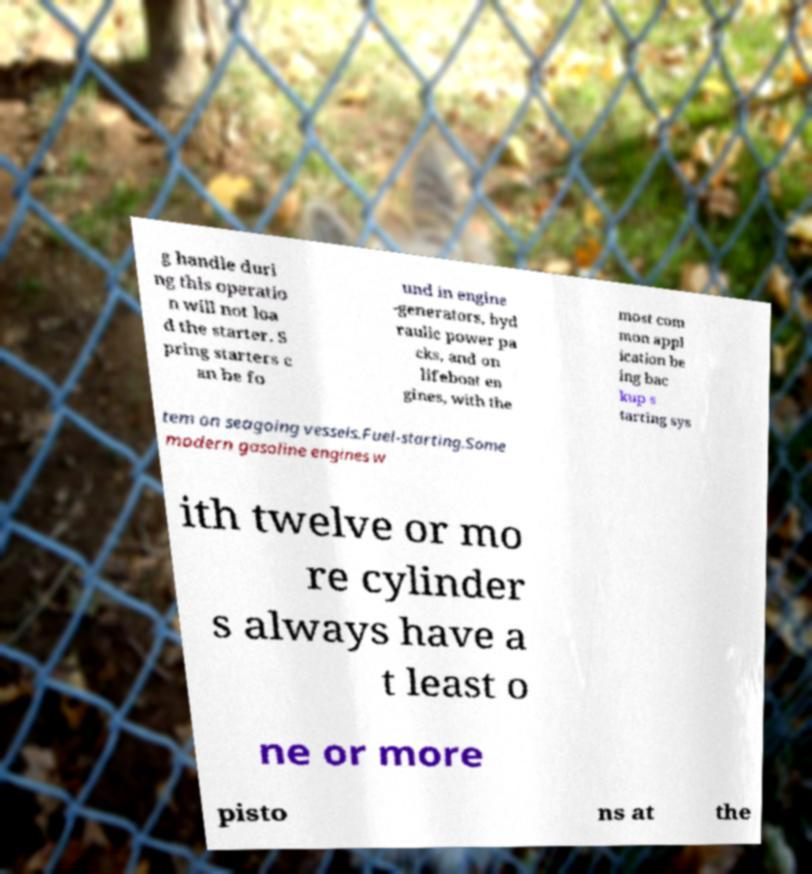Could you extract and type out the text from this image? g handle duri ng this operatio n will not loa d the starter. S pring starters c an be fo und in engine -generators, hyd raulic power pa cks, and on lifeboat en gines, with the most com mon appl ication be ing bac kup s tarting sys tem on seagoing vessels.Fuel-starting.Some modern gasoline engines w ith twelve or mo re cylinder s always have a t least o ne or more pisto ns at the 